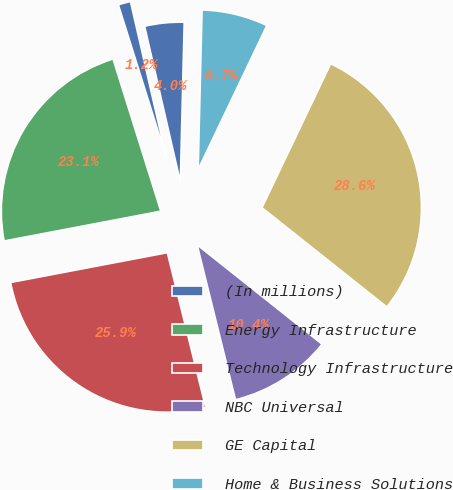Convert chart. <chart><loc_0><loc_0><loc_500><loc_500><pie_chart><fcel>(In millions)<fcel>Energy Infrastructure<fcel>Technology Infrastructure<fcel>NBC Universal<fcel>GE Capital<fcel>Home & Business Solutions<fcel>Corporate items and<nl><fcel>1.25%<fcel>23.15%<fcel>25.87%<fcel>10.45%<fcel>28.6%<fcel>6.7%<fcel>3.98%<nl></chart> 